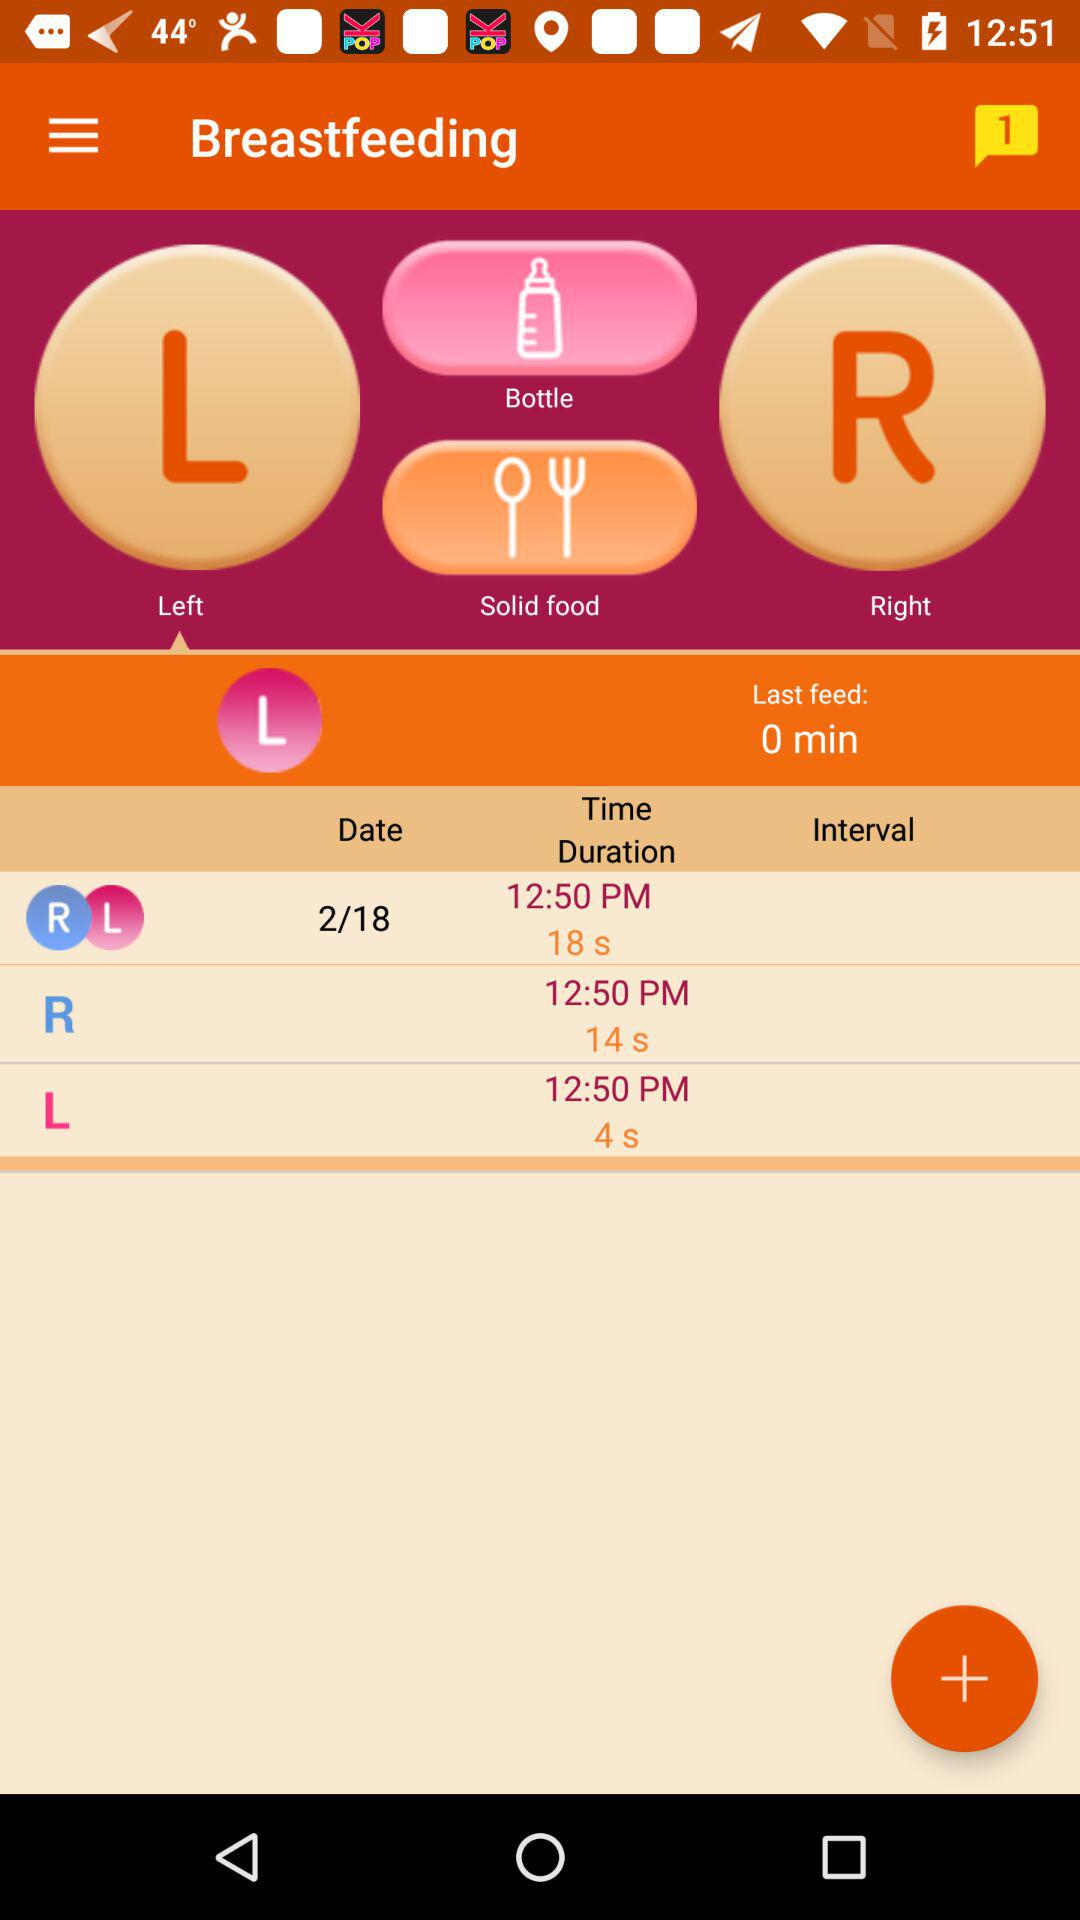What is the duration of the last feed? The duration is 0 minutes. 